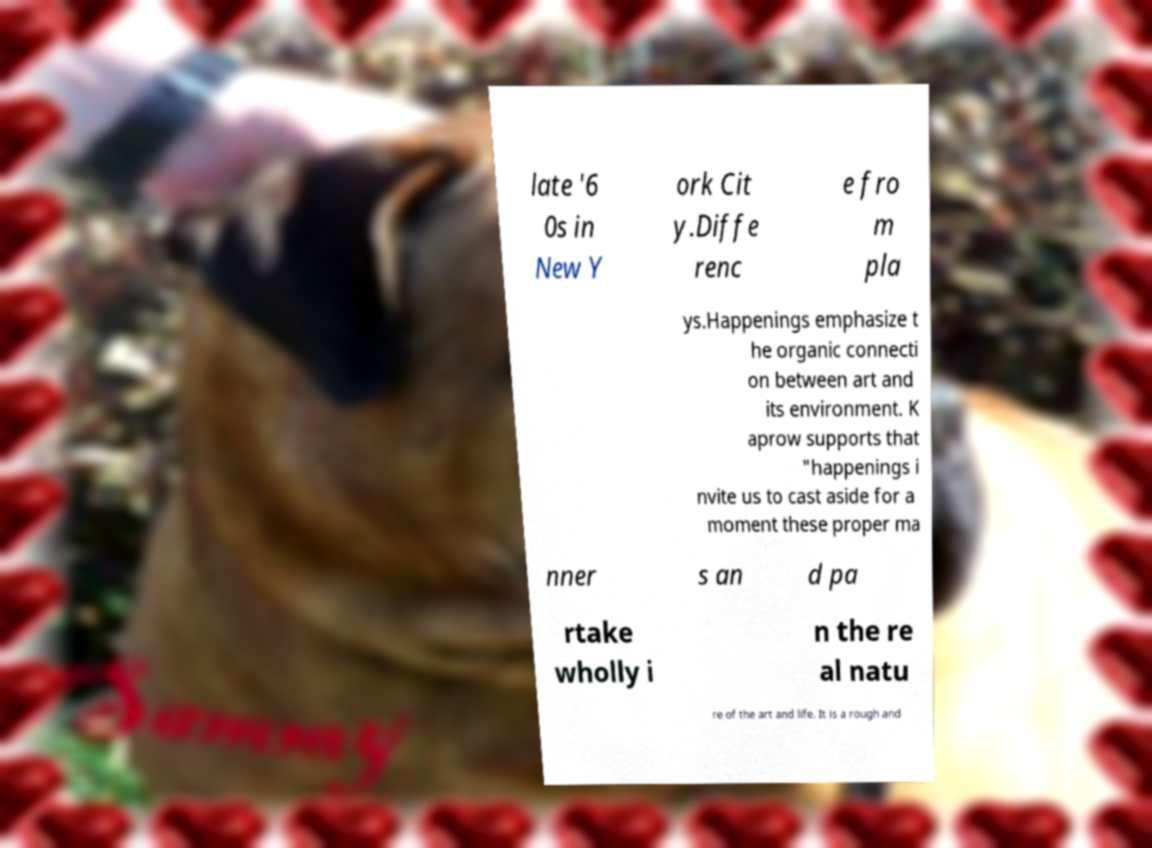Can you read and provide the text displayed in the image?This photo seems to have some interesting text. Can you extract and type it out for me? late '6 0s in New Y ork Cit y.Diffe renc e fro m pla ys.Happenings emphasize t he organic connecti on between art and its environment. K aprow supports that "happenings i nvite us to cast aside for a moment these proper ma nner s an d pa rtake wholly i n the re al natu re of the art and life. It is a rough and 